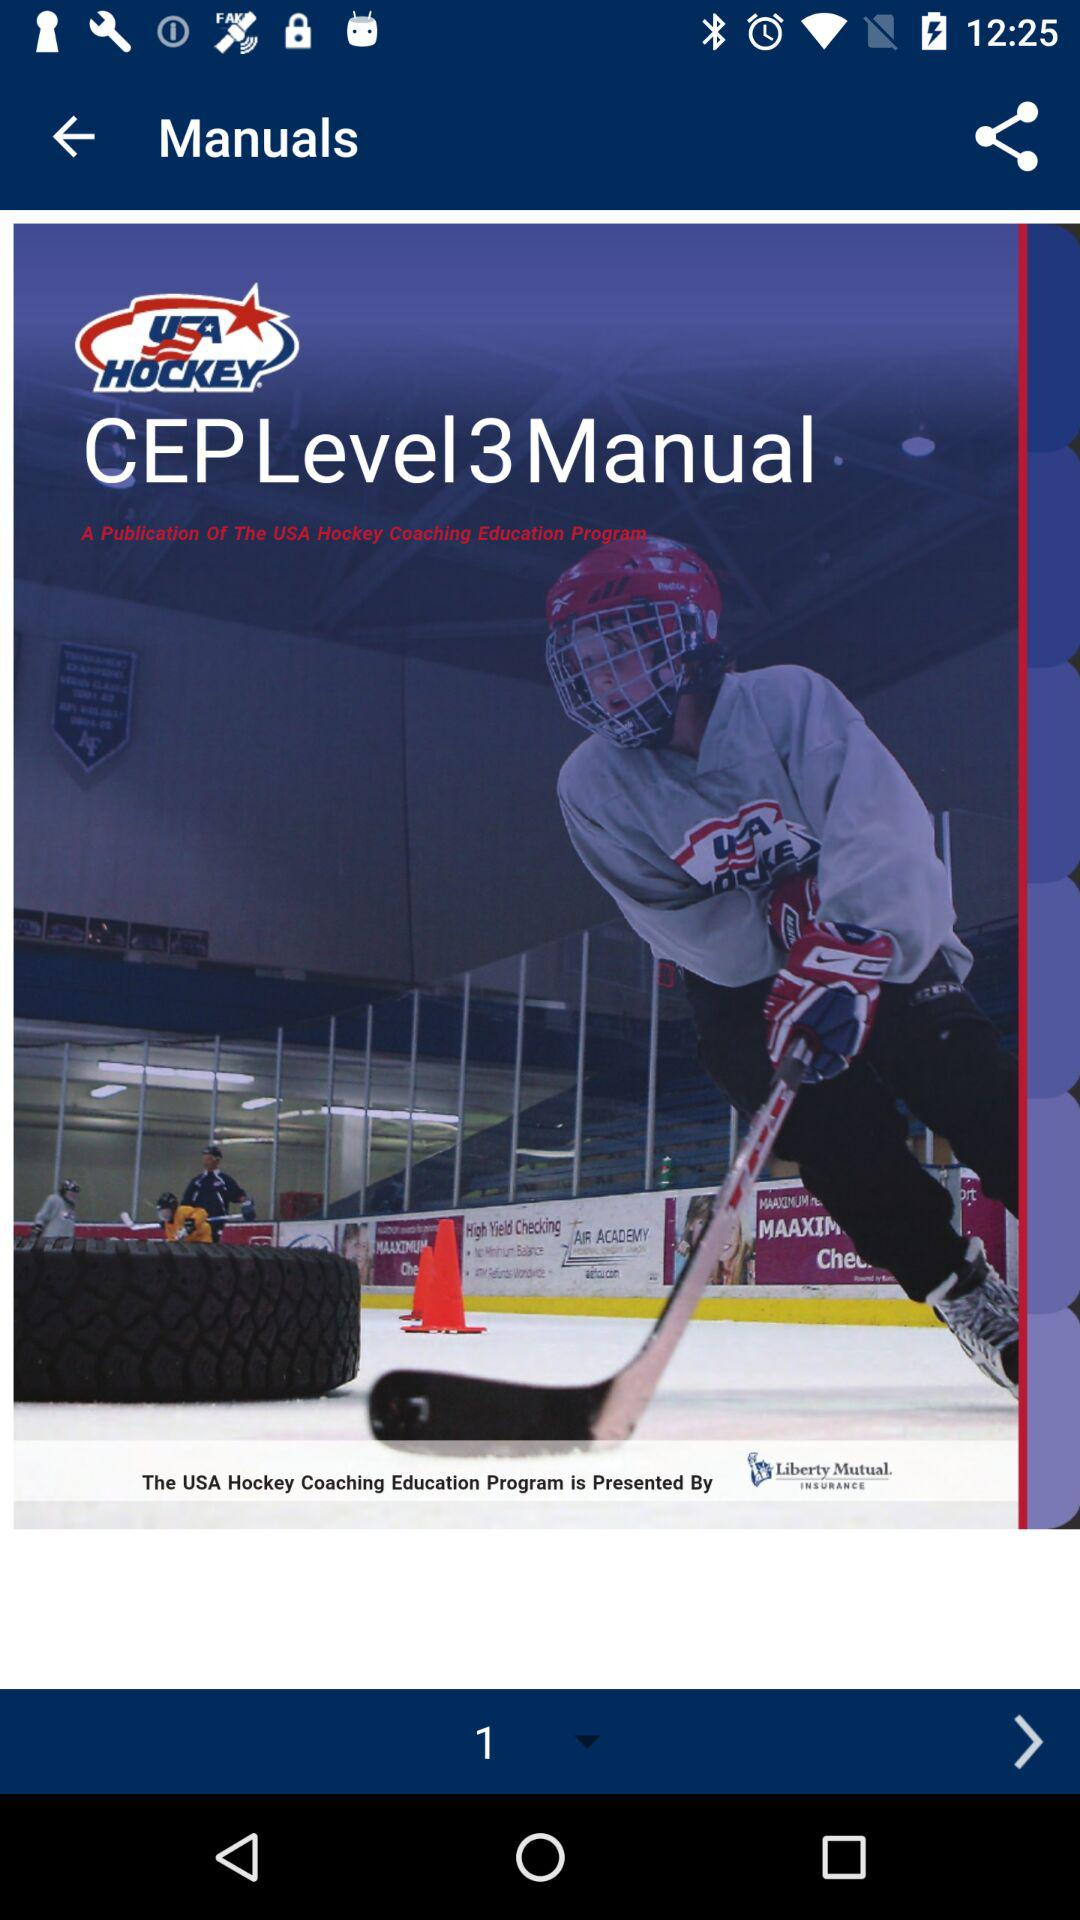What is the name of the application? The name of the application is "USA Hockey Events". 